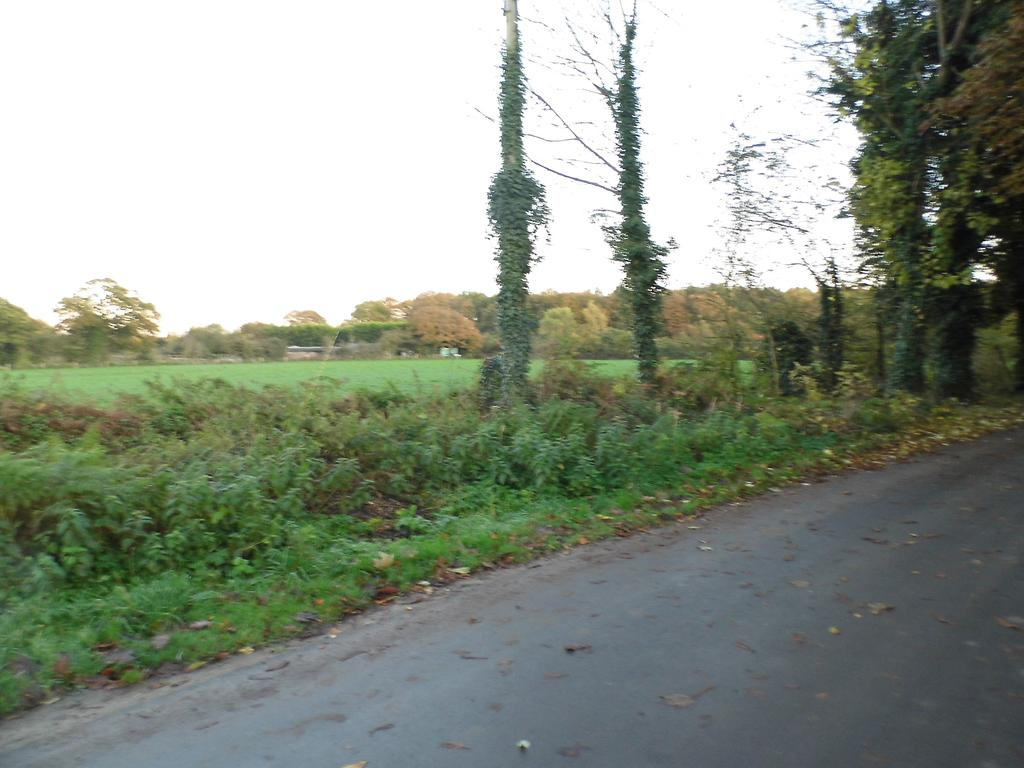What is the main feature of the image? There is a road in the image. What else can be seen in the image besides the road? There are plants and trees in the image. What is visible in the background of the image? The sky is visible in the background of the image. What type of list can be seen hanging from the trees in the image? There is no list present in the image; it features a road, plants, trees, and the sky. 